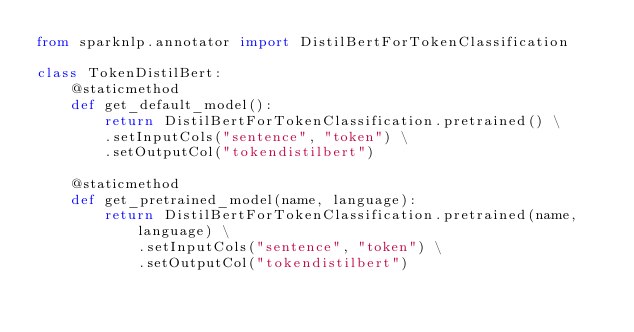<code> <loc_0><loc_0><loc_500><loc_500><_Python_>from sparknlp.annotator import DistilBertForTokenClassification

class TokenDistilBert:
    @staticmethod
    def get_default_model():
        return DistilBertForTokenClassification.pretrained() \
        .setInputCols("sentence", "token") \
        .setOutputCol("tokendistilbert")

    @staticmethod
    def get_pretrained_model(name, language):
        return DistilBertForTokenClassification.pretrained(name, language) \
            .setInputCols("sentence", "token") \
            .setOutputCol("tokendistilbert")



</code> 